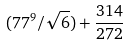<formula> <loc_0><loc_0><loc_500><loc_500>( 7 7 ^ { 9 } / \sqrt { 6 } ) + \frac { 3 1 4 } { 2 7 2 }</formula> 